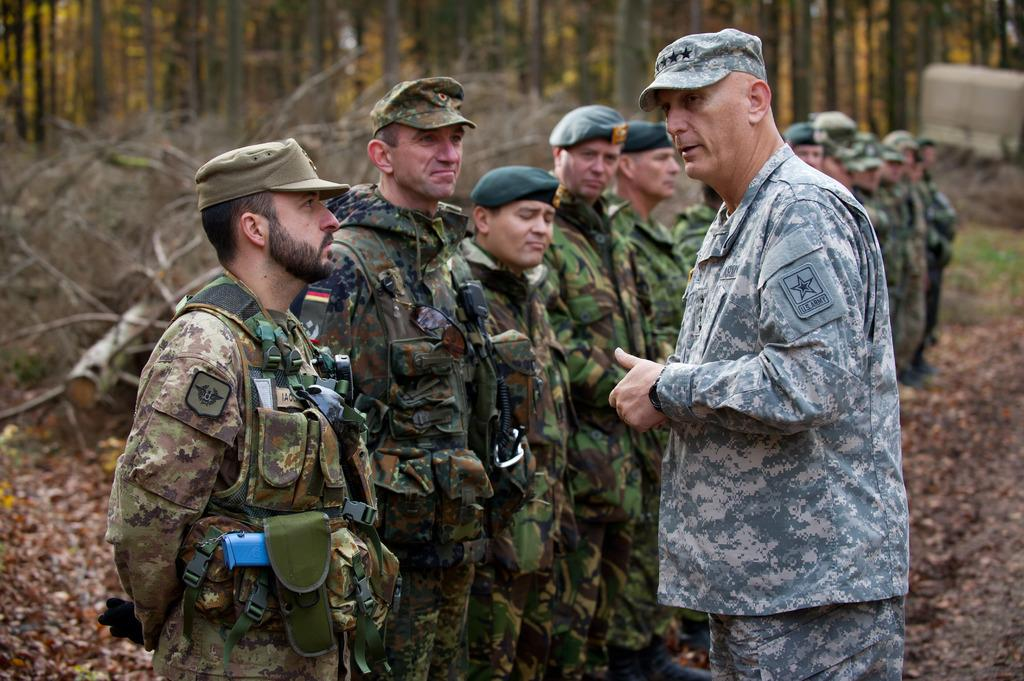What are the soldiers doing in the image? The soldiers are standing in a row in the image. Is there anyone else present in the image besides the soldiers? Yes, there is a person standing in front of the soldiers in the right corner of the image. What can be seen in the background of the image? There are trees in the background of the image. What type of metal can be seen starting to rust in the image? There is no metal present in the image, so it is not possible to determine if any metal is rusting. 